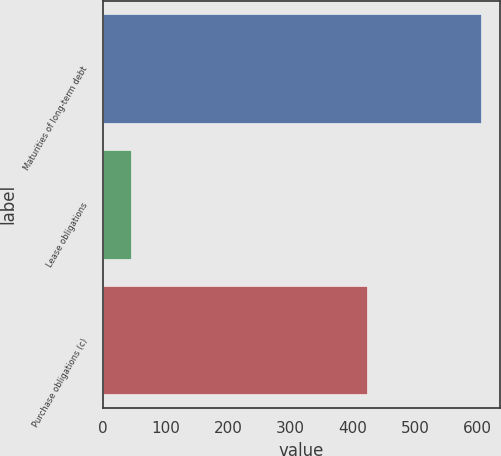Convert chart. <chart><loc_0><loc_0><loc_500><loc_500><bar_chart><fcel>Maturities of long-term debt<fcel>Lease obligations<fcel>Purchase obligations (c)<nl><fcel>605<fcel>45<fcel>422<nl></chart> 